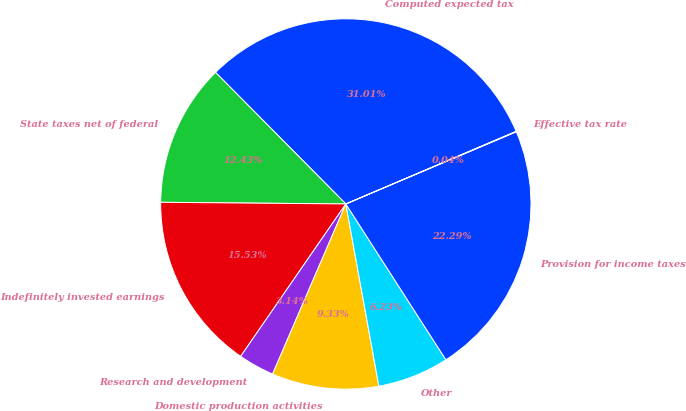Convert chart. <chart><loc_0><loc_0><loc_500><loc_500><pie_chart><fcel>Computed expected tax<fcel>State taxes net of federal<fcel>Indefinitely invested earnings<fcel>Research and development<fcel>Domestic production activities<fcel>Other<fcel>Provision for income taxes<fcel>Effective tax rate<nl><fcel>31.01%<fcel>12.43%<fcel>15.53%<fcel>3.14%<fcel>9.33%<fcel>6.23%<fcel>22.29%<fcel>0.04%<nl></chart> 